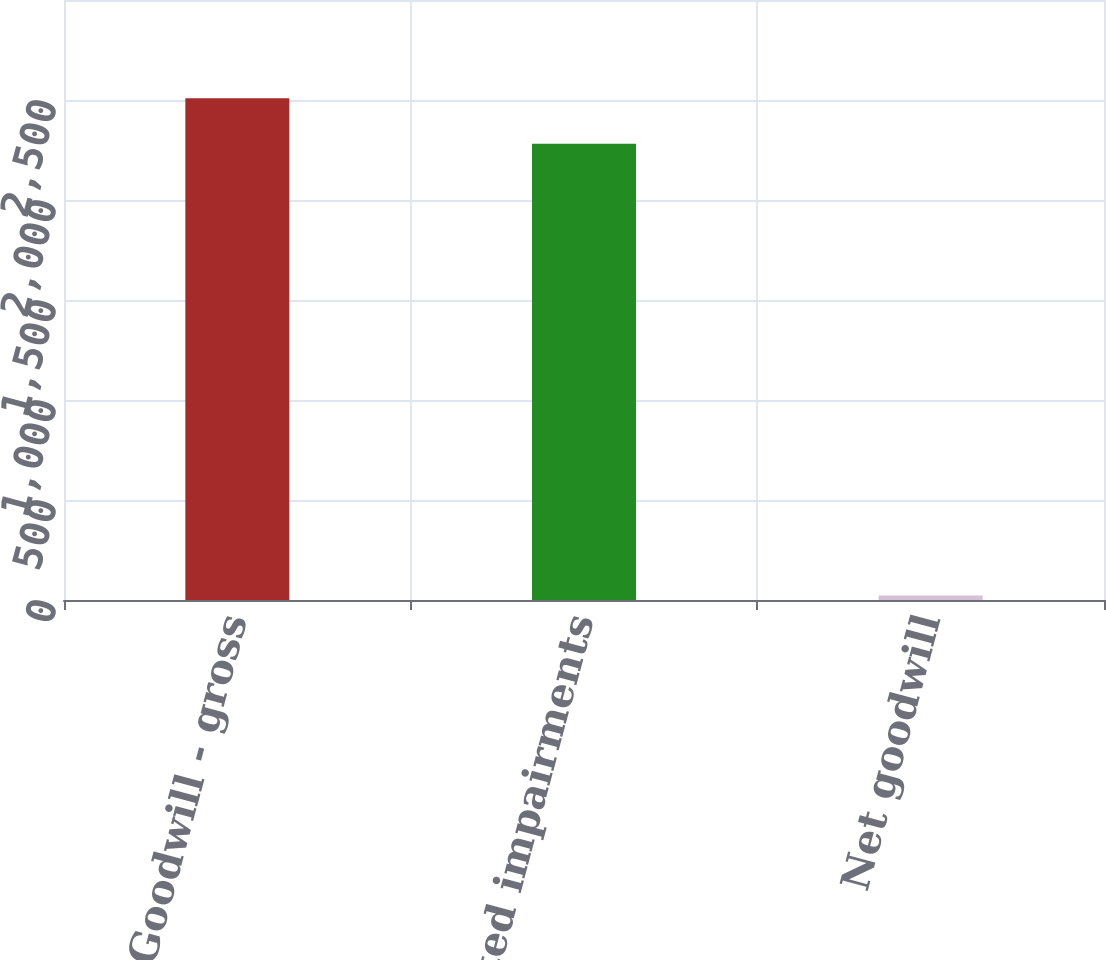<chart> <loc_0><loc_0><loc_500><loc_500><bar_chart><fcel>Goodwill - gross<fcel>Accumulated impairments<fcel>Net goodwill<nl><fcel>2509.1<fcel>2281<fcel>23<nl></chart> 